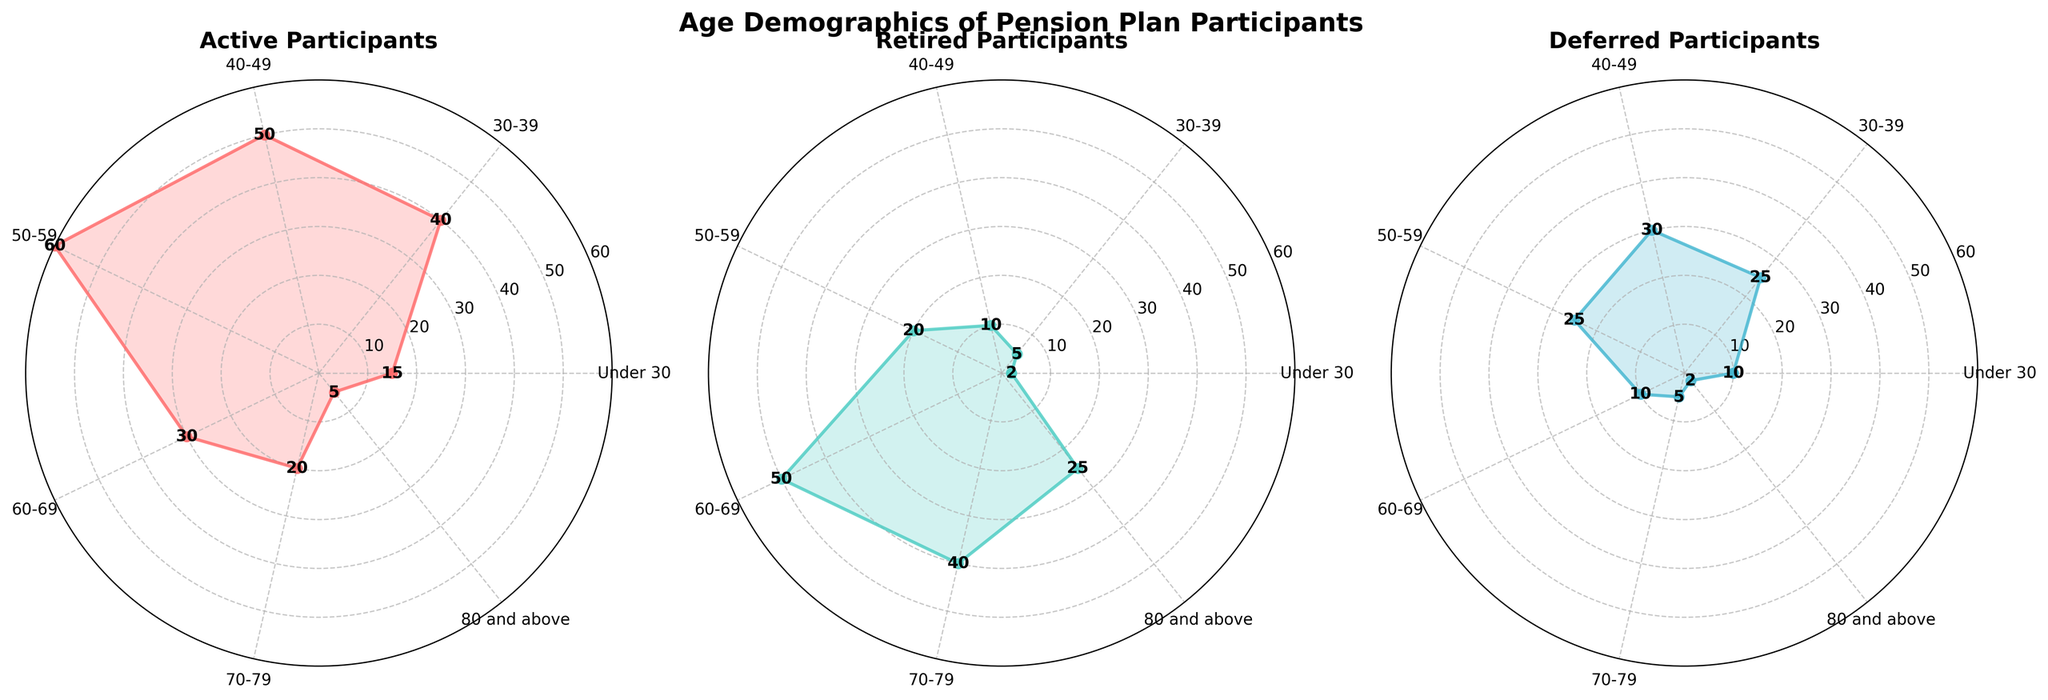What's the title of the figure? The title is located at the top center of the figure. It summarizes the overall content of the figure.
Answer: Age Demographics of Pension Plan Participants How many age groups are represented in the figure? By counting the distinct sections or labels used in the radar chart's axis, we can determine the number of age groups.
Answer: 7 Which participant category has the highest number in the 50-59 age group? By looking at the data points in the 50-59 section for each radar chart, we can see which category's line reaches the highest value.
Answer: Active Participants In the 'Under 30' age group, how many more active participants are there compared to retired participants? Subtract the number of retired participants in the 'Under 30' age group from the number of active participants to find the difference.
Answer: 13 Between the '30-39' and '40-49' age groups, which has a higher number of deferred participants? Compare the data points for deferred participants in the '30-39' and '40-49' age groups to see which is higher.
Answer: 40-49 Compare the '70-79' and '80 and above' age groups: in which age group do retired participants exceed active participants more? Calculate the difference between retired and active participants for both the '70-79' and '80 and above' age groups and compare those differences.
Answer: 80 and above Is the number of retired participants consistently increasing with age? Examine the trend of the retired participants' line on the radar chart to see if the values steadily rise with each successive age group.
Answer: No What is the total number of active participants in all age groups combined? Sum up the values of active participants across all age groups.
Answer: 220 In which participant category do 'Deferred Participants' have the least value, and what is that value? Identify the lowest point on the radar chart representing deferred participants and note the corresponding age group and value.
Answer: 80 and above, 2 